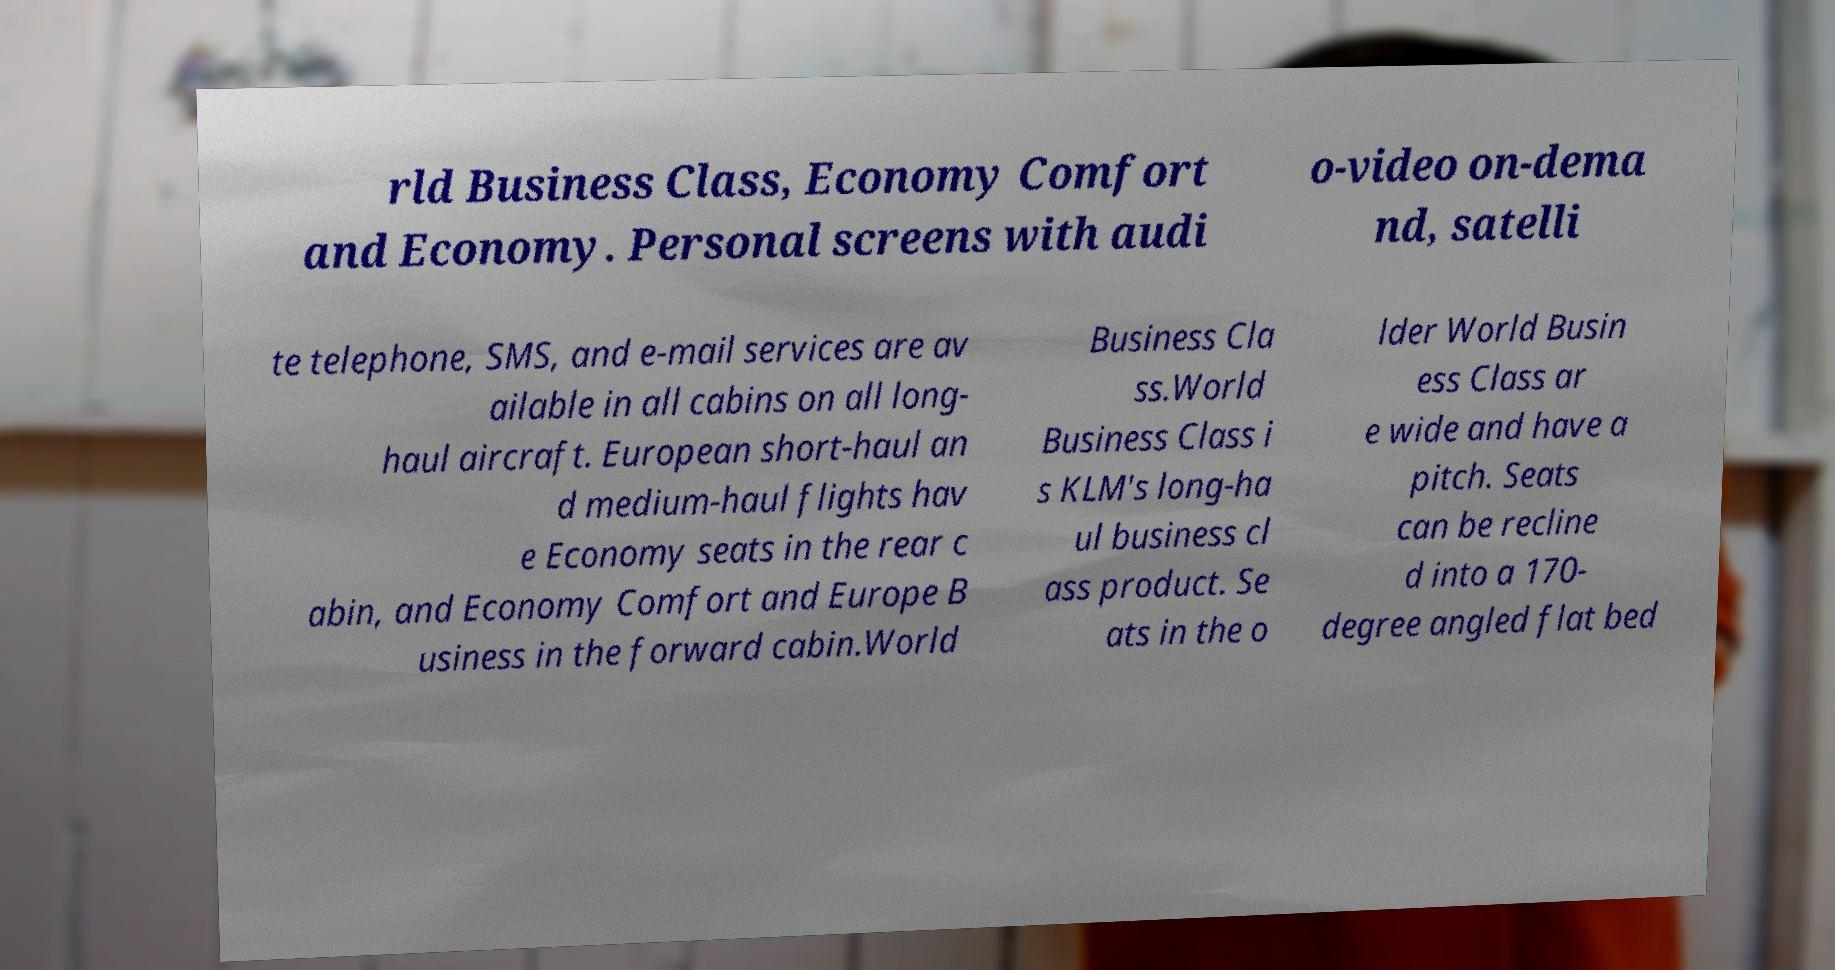Could you assist in decoding the text presented in this image and type it out clearly? rld Business Class, Economy Comfort and Economy. Personal screens with audi o-video on-dema nd, satelli te telephone, SMS, and e-mail services are av ailable in all cabins on all long- haul aircraft. European short-haul an d medium-haul flights hav e Economy seats in the rear c abin, and Economy Comfort and Europe B usiness in the forward cabin.World Business Cla ss.World Business Class i s KLM's long-ha ul business cl ass product. Se ats in the o lder World Busin ess Class ar e wide and have a pitch. Seats can be recline d into a 170- degree angled flat bed 